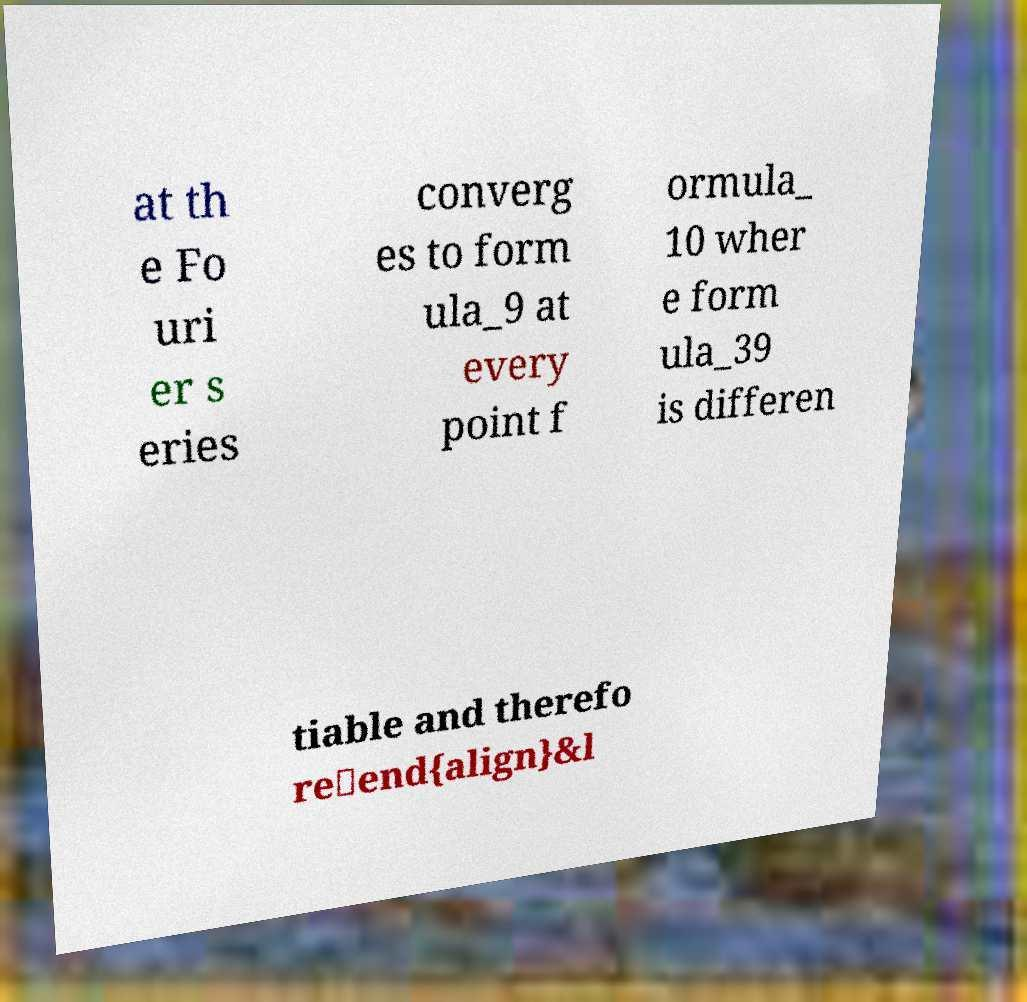Please identify and transcribe the text found in this image. at th e Fo uri er s eries converg es to form ula_9 at every point f ormula_ 10 wher e form ula_39 is differen tiable and therefo re\end{align}&l 